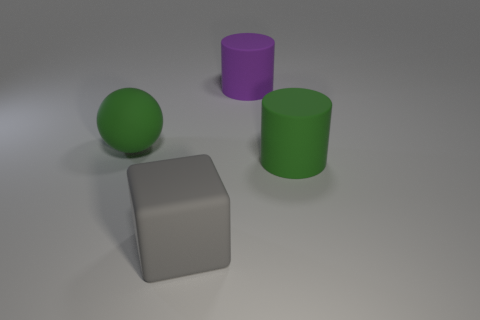Add 4 large green things. How many objects exist? 8 Subtract all balls. How many objects are left? 3 Add 4 green matte objects. How many green matte objects exist? 6 Subtract 0 cyan cylinders. How many objects are left? 4 Subtract all tiny blue matte cubes. Subtract all matte things. How many objects are left? 0 Add 3 purple rubber things. How many purple rubber things are left? 4 